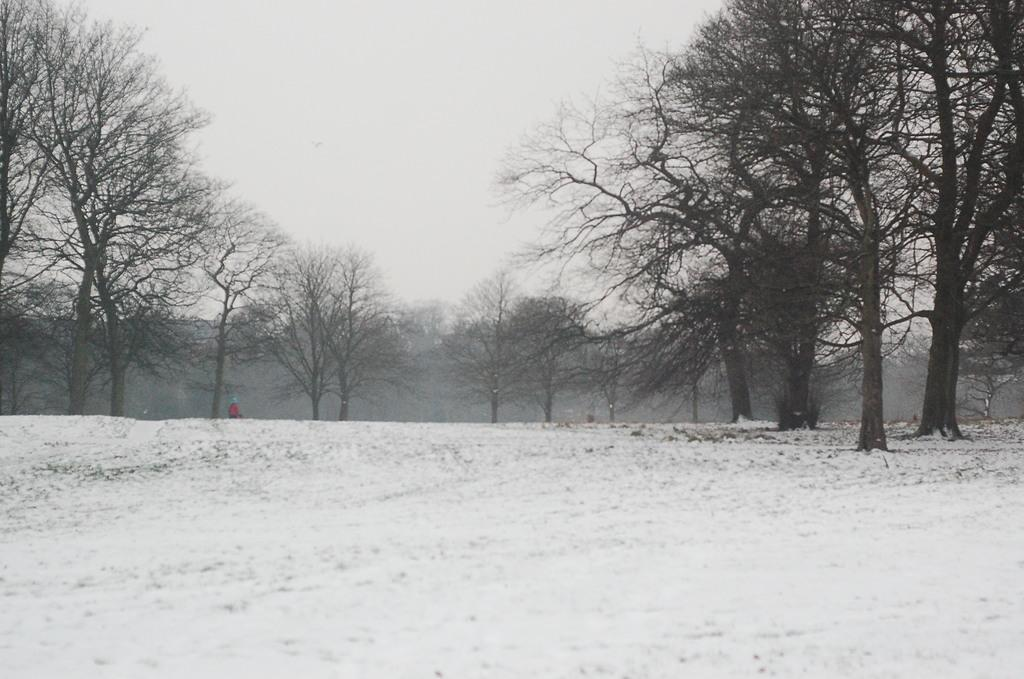What is the man in the image standing on? The man is standing on ice in the image. What can be seen in the background of the image? There are trees in the background of the image. How would you describe the sky in the image? The sky is visible in the image and appears cloudy. What type of zinc structure can be seen in the image? There is no zinc structure present in the image. Is there a building visible in the image? No, there is no building visible in the image; only trees are mentioned in the background. 